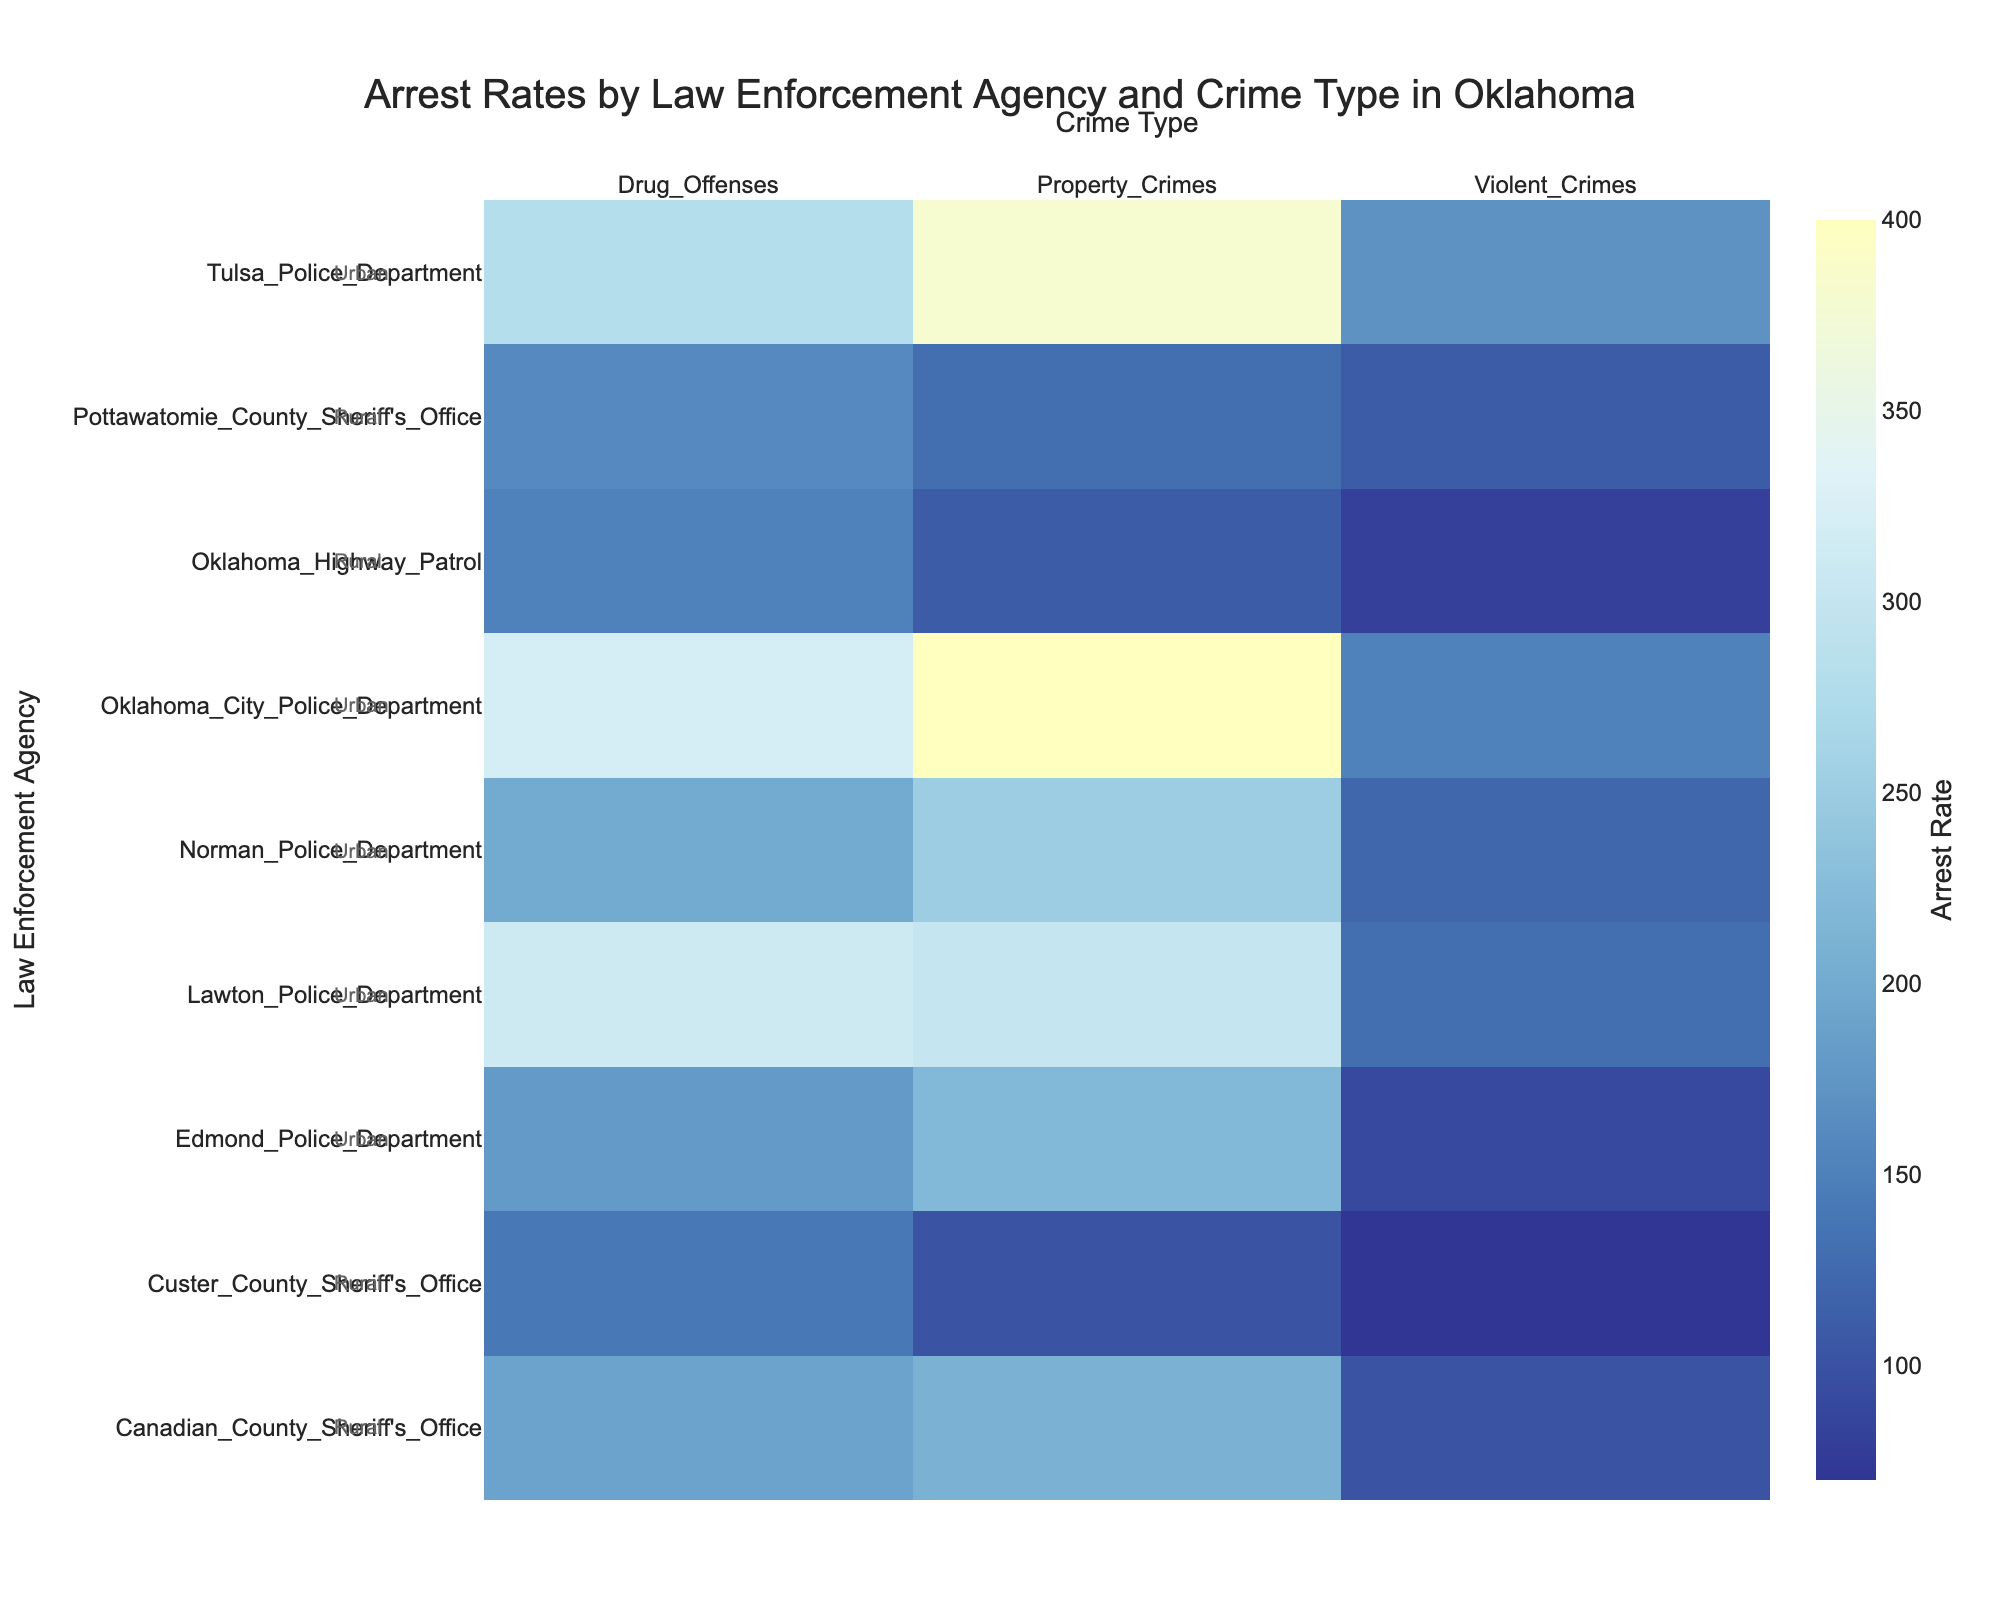What is the title of the Heatmap? The title of the Heatmap is written at the top center of the figure.
Answer: Arrest Rates by Law Enforcement Agency and Crime Type in Oklahoma Which urban law enforcement agency has the highest arrest rate for property crimes? Scanning the 'Property Crimes' column for urban agencies, Oklahoma City Police Department has the highest value.
Answer: Oklahoma City Police Department In which type of area does the Lawton Police Department operate, urban or rural? According to the annotations next to the agencies, Lawton Police Department is labeled as urban.
Answer: Urban What is the arrest rate for drug offenses by Oklahoma Highway Patrol? Locate Oklahoma Highway Patrol on the y-axis and intersect it with the 'Drug Offenses' column.
Answer: 150 What is the combined arrest rate for property crimes in rural areas? Sum the arrest rates for property crimes by rural agencies: Oklahoma Highway Patrol (110), Custer County Sheriff's Office (100), Pottawatomie County Sheriff's Office (130), Canadian County Sheriff's Office (210).
Answer: 550 How does the arrest rate for violent crimes by Tulsa Police Department compare to that by Edmond Police Department? Compare the values in the 'Violent Crimes' column for the respective agencies: Tulsa (170) and Edmond (90). Tulsa's rate is higher.
Answer: Tulsa Police Department's rate is higher What is the average arrest rate for drug offenses by rural law enforcement agencies? Find the values for rural agencies and compute the average: (150+140+160+190)/4.
Answer: 160 Which type of crime has the lowest arrest rate for Norman Police Department? Look at the arrest rates for all types of crimes by Norman Police Department and find the minimum value.
Answer: Violent Crimes By how much does the arrest rate for property crimes in Oklahoma City exceed that in Edmond? Subtract the property crime arrest rate for Edmond Police Department from Oklahoma City Police Department: 400-220.
Answer: 180 Which rural agency has the highest arrest rate for drug offenses? Among the rural agencies listed in the 'Drug Offenses' category, Canadian County Sheriff's Office has the highest value.
Answer: Canadian County Sheriff's Office 